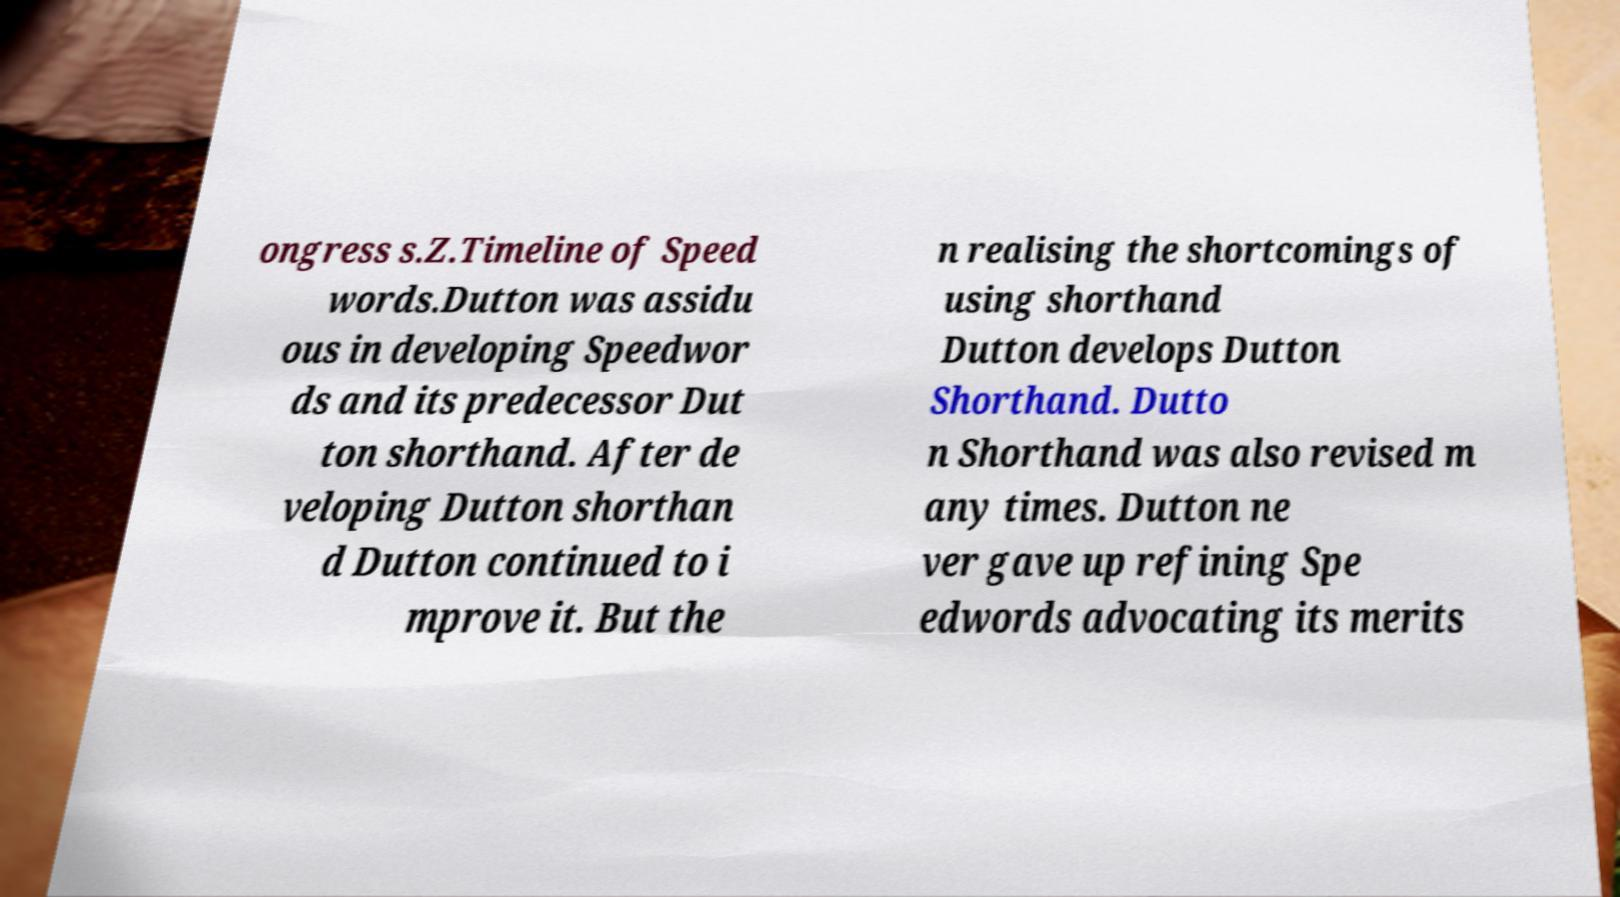What messages or text are displayed in this image? I need them in a readable, typed format. ongress s.Z.Timeline of Speed words.Dutton was assidu ous in developing Speedwor ds and its predecessor Dut ton shorthand. After de veloping Dutton shorthan d Dutton continued to i mprove it. But the n realising the shortcomings of using shorthand Dutton develops Dutton Shorthand. Dutto n Shorthand was also revised m any times. Dutton ne ver gave up refining Spe edwords advocating its merits 